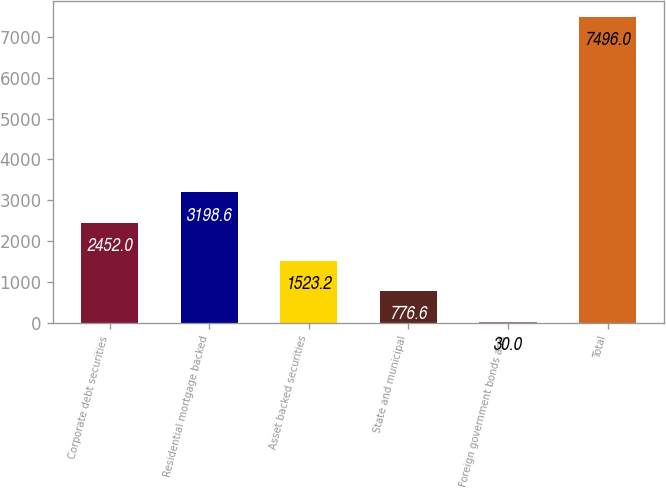Convert chart to OTSL. <chart><loc_0><loc_0><loc_500><loc_500><bar_chart><fcel>Corporate debt securities<fcel>Residential mortgage backed<fcel>Asset backed securities<fcel>State and municipal<fcel>Foreign government bonds and<fcel>Total<nl><fcel>2452<fcel>3198.6<fcel>1523.2<fcel>776.6<fcel>30<fcel>7496<nl></chart> 